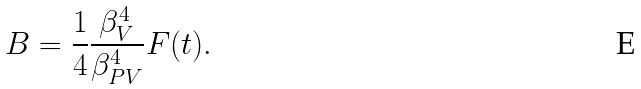Convert formula to latex. <formula><loc_0><loc_0><loc_500><loc_500>B = \frac { 1 } { 4 } \frac { \beta _ { V } ^ { 4 } } { \beta _ { P V } ^ { 4 } } F ( t ) .</formula> 